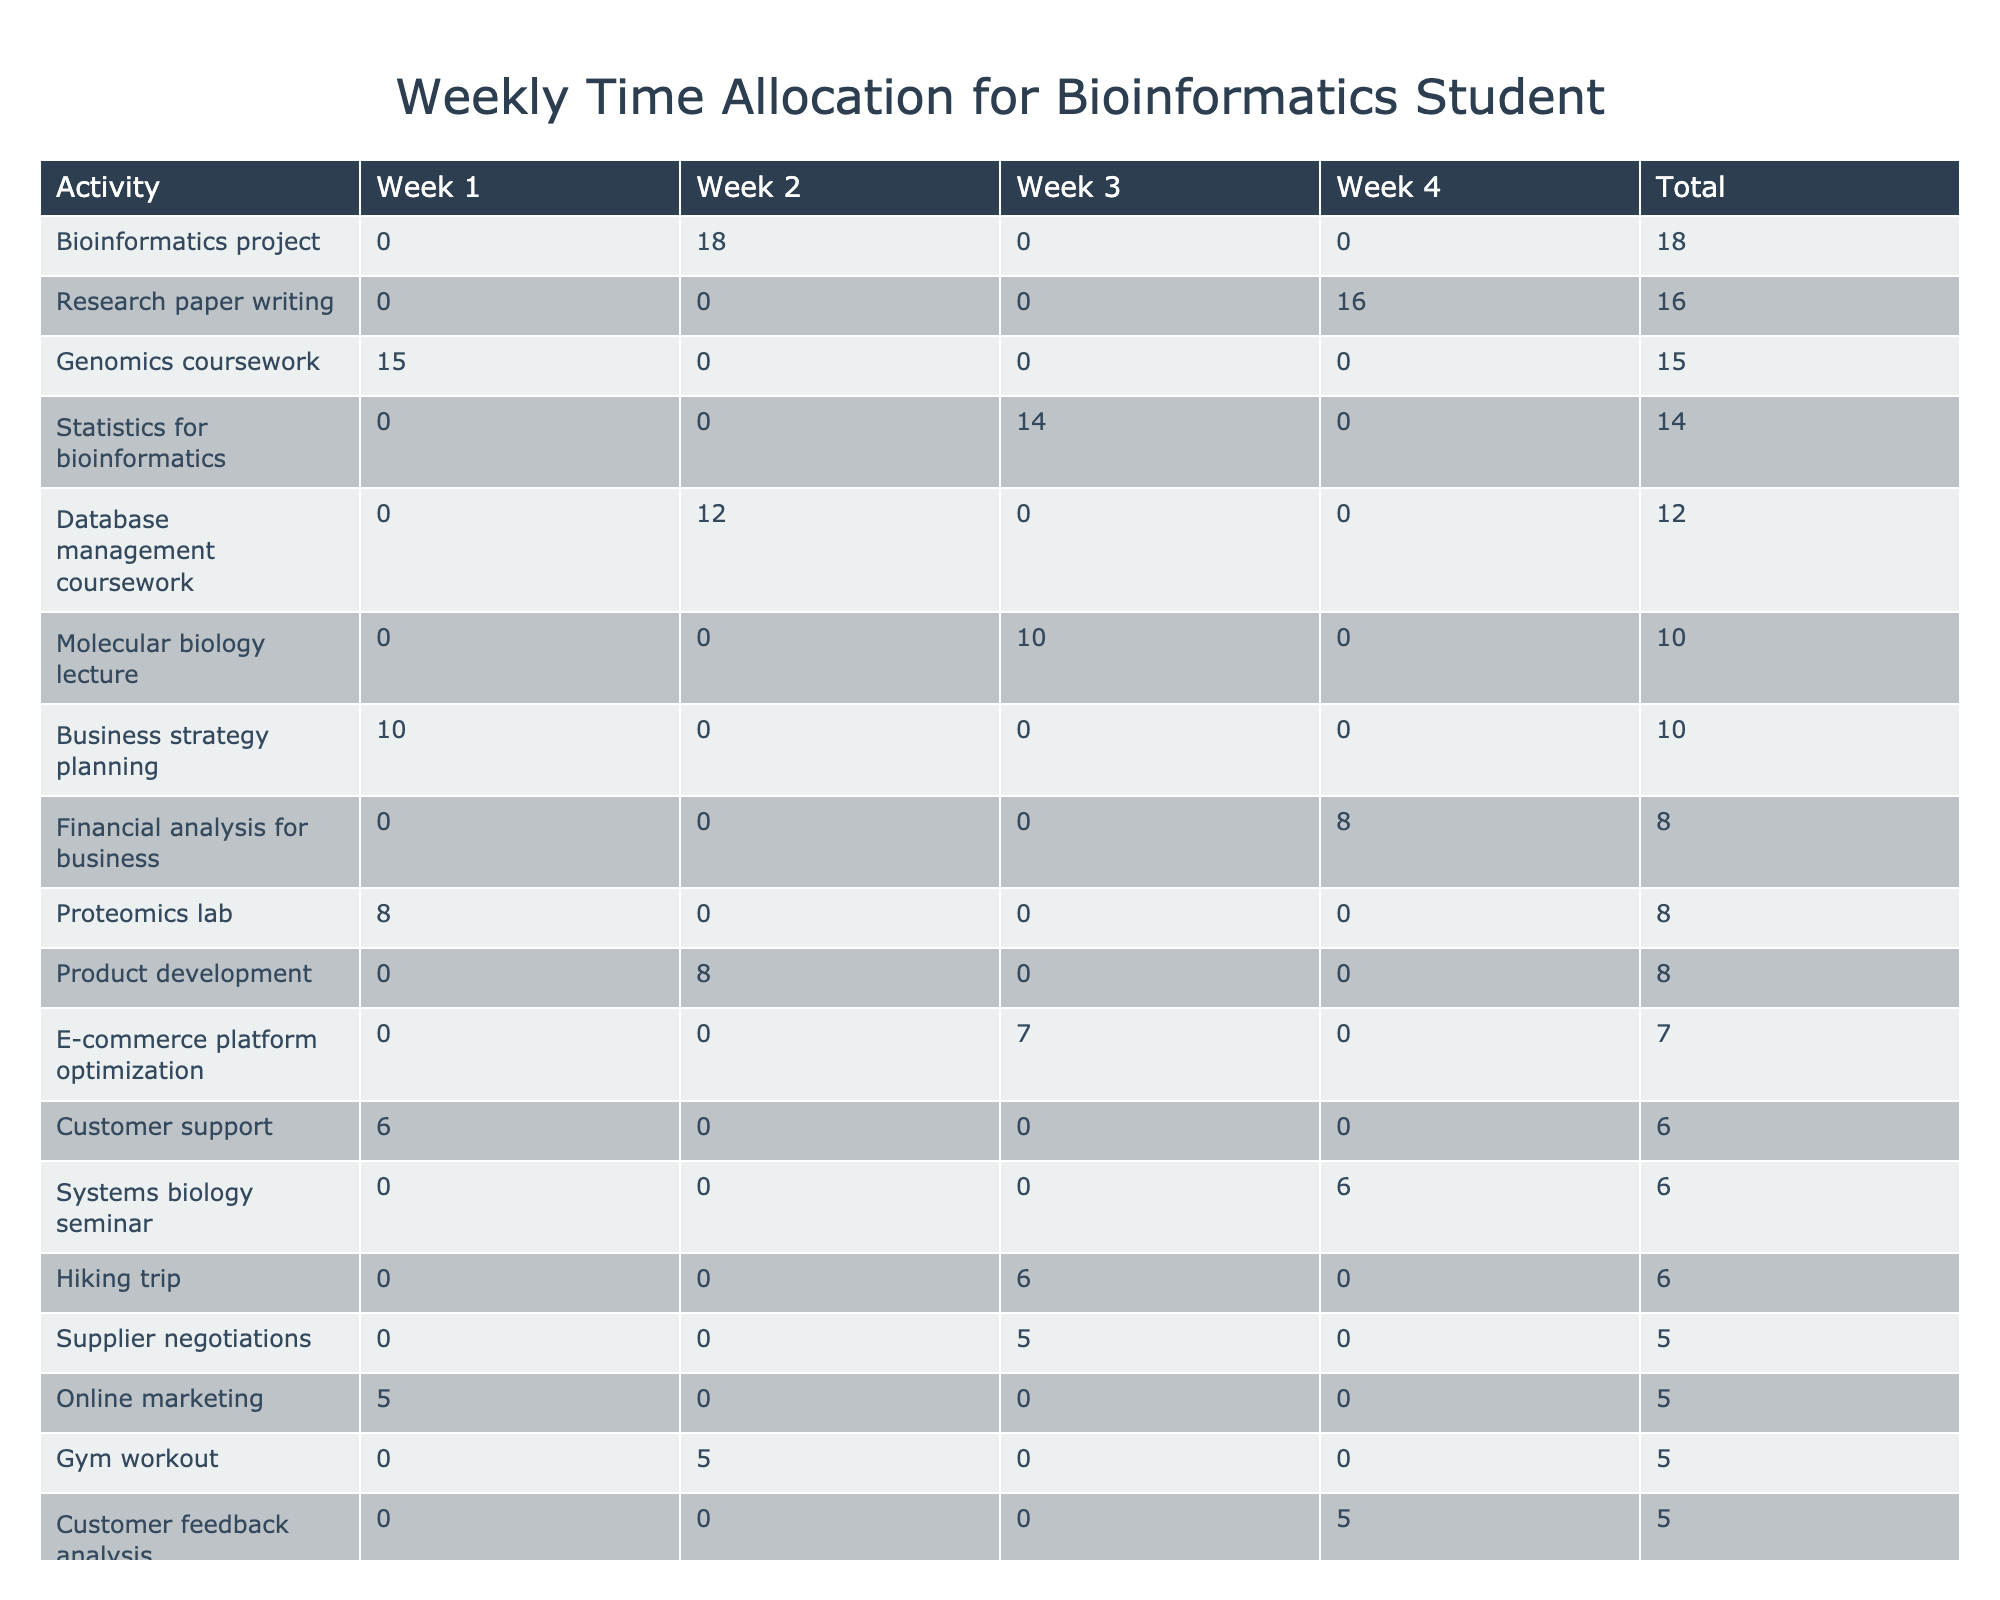What is the total time spent on Genomics coursework during the first week? The table shows that for the first week, 15 hours are allocated to Genomics coursework.
Answer: 15 hours Which activity had the lowest total hours across all weeks? By reviewing the total column in the table, the activity with the lowest total is "Swimming," which has 3 hours.
Answer: Swimming What is the combined total time spent on coursework (Genomics and Database management) in week 2? For week 2, Genomics coursework has 18 hours and Database management coursework has 12 hours. Adding these gives 18 + 12 = 30 hours.
Answer: 30 hours Did the time spent on customer support increase from week 1 to week 4? In week 1, 6 hours were spent on customer support, while in week 4, 5 hours were spent. Since 6 is greater than 5, the time spent decreased.
Answer: No What is the total time allocated for leisure activities in week 3? In week 3, leisure activities include Yoga session (3 hours), Hiking trip (6 hours), and Movie night with friends (3 hours). The sum is 3 + 6 + 3 = 12 hours.
Answer: 12 hours Which coursework activity had the highest total hours across all weeks, and how many hours were dedicated to it? By analyzing the total column, "Research paper writing" is the highest with 16 hours.
Answer: Research paper writing; 16 hours How many total hours were spent on E-commerce tasks (including online marketing and platform optimization) in week 3? In week 3, online marketing has 5 hours and platform optimization has 7 hours. The total is 5 + 7 = 12 hours.
Answer: 12 hours What is the average amount of time spent on leisure activities across all weeks? The total hours for leisure activities across all weeks are 4 (video gaming) + 3 (Netflix binge) + 3 (movie night) + 6 (hiking) + 3 (yoga) + 3 (swimming) = 22 hours, divided by the number of weeks (4), gives 22 / 4 = 5.5 hours.
Answer: 5.5 hours Which week had the highest total hours allocated for business tasks, and what was the total? By reviewing the table, week 1 had 10 hours for business strategy planning, 6 for customer support, and 5 for online marketing, totaling 21 hours, which is higher than any other week.
Answer: Week 1; 21 hours Is the time spent on running the business in week 1 greater than the total time spent on coursework in week 3? The total hours for business tasks in week 1 is 21 (10 for strategy + 6 for support + 5 for marketing) and for coursework in week 3 is 24 (10 for the lecture + 14 for Statistics). Since 21 is less than 24, the statement is false.
Answer: No 